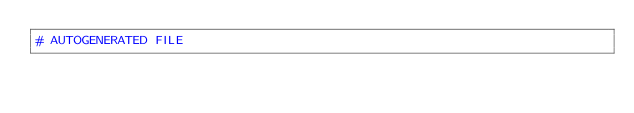Convert code to text. <code><loc_0><loc_0><loc_500><loc_500><_Dockerfile_># AUTOGENERATED FILE</code> 